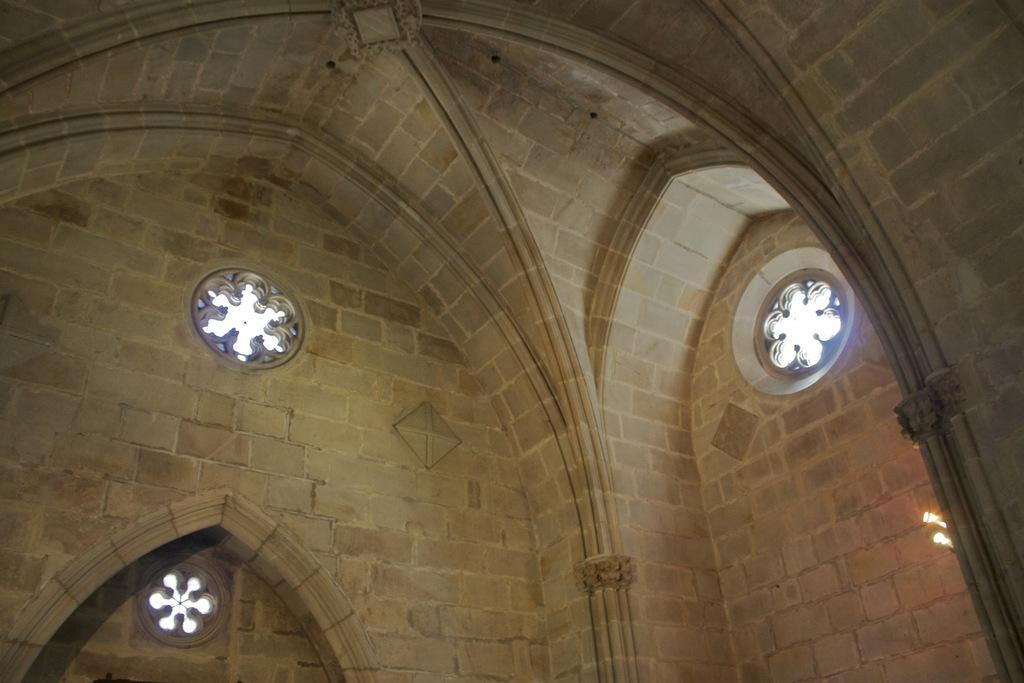Where was the image taken? The image was taken indoors. What can be seen above the indoor space in the image? There is a roof visible in the image. What architectural feature is present in the image? There is an arch in the image. What allows natural light to enter the indoor space in the image? There are windows in the image. What type of sheet is hanging from the arch in the image? There is no sheet hanging from the arch in the image. Can you see a playground in the image? There is no playground present in the image. 